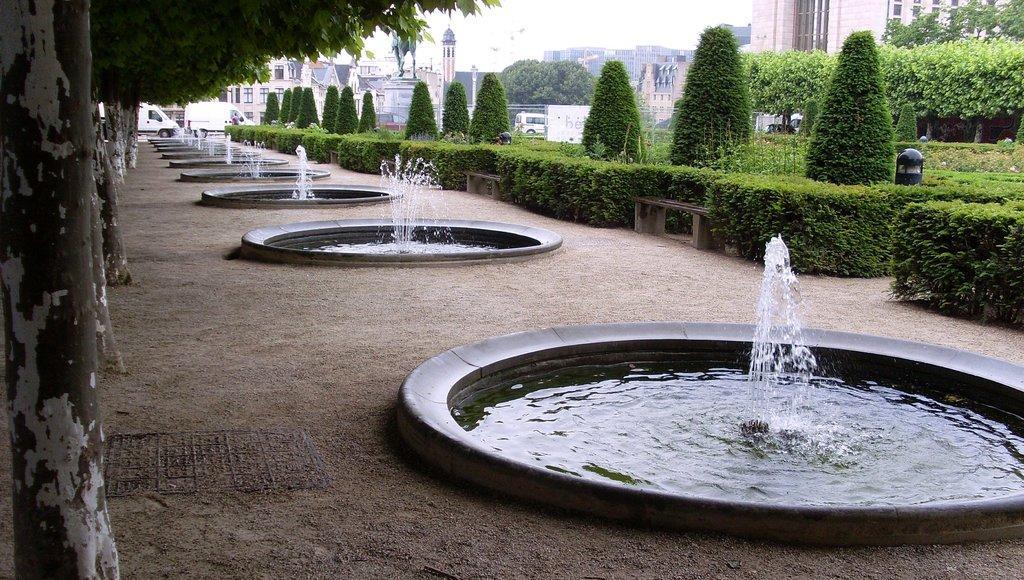How would you summarize this image in a sentence or two? In this image I can see water fountains, bushes, few benches, number of trees and here I can see a black colour thing. In the background I can see few vehicles and number of buildings. 